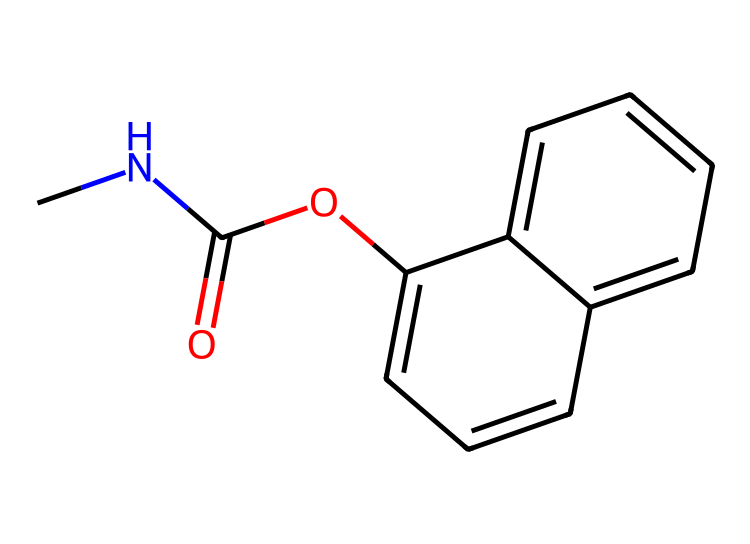How many carbon atoms are in the molecular structure of carbaryl? By examining the SMILES representation, we can count the carbon atoms indicated: there are two carbon atoms represented in "CNC(=O)O" and additional carbon atoms connected in the aromatic rings "c1cccc2ccccc12." Counting all, we find a total of 10 carbon atoms.
Answer: 10 What functional groups are present in carbaryl? The SMILES representation includes groups identifiable as a carbamate (indicated by "C(=O)O") and an amine (as indicated by "CNC"). Therefore, the main functional groups are carbamate and amine.
Answer: carbamate, amine How many nitrogen atoms are in the structure of carbaryl? In the SMILES code, the letter "N" indicates the presence of one nitrogen atom. By reviewing the entire structure, we confirm that only one nitrogen atom is visible.
Answer: 1 What type of pesticide is carbaryl classified as? Carbaryl is known as a broad-spectrum insecticide. This classification is based on its functionality and application to control various insect pests in gardening products.
Answer: insecticide Which part of the molecule contributes to carbaryl's insecticidal properties? The carbamate functional group ("C(=O)O") is critical for the insecticidal activity of carbaryl. Carbamates generally inhibit the enzyme acetylcholinesterase, which is crucial for nerve function in insects.
Answer: carbamate How many rings are in the carbaryl structure? Upon analyzing the structure depicted in the SMILES, the two interconnected aromatic rings can be seen. This accounts for a total of 2 rings in the molecular structure.
Answer: 2 